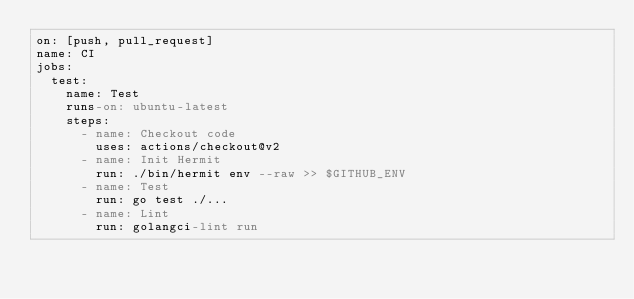<code> <loc_0><loc_0><loc_500><loc_500><_YAML_>on: [push, pull_request]
name: CI
jobs:
  test:
    name: Test
    runs-on: ubuntu-latest
    steps:
      - name: Checkout code
        uses: actions/checkout@v2
      - name: Init Hermit
        run: ./bin/hermit env --raw >> $GITHUB_ENV
      - name: Test
        run: go test ./...
      - name: Lint
        run: golangci-lint run
</code> 